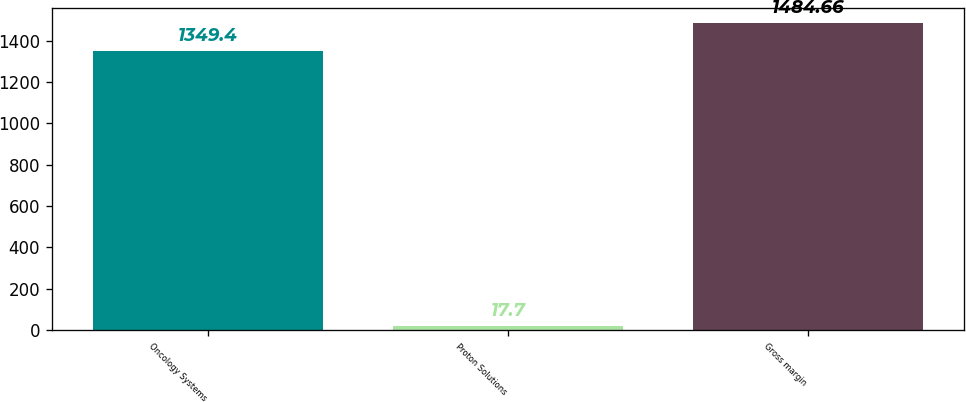Convert chart. <chart><loc_0><loc_0><loc_500><loc_500><bar_chart><fcel>Oncology Systems<fcel>Proton Solutions<fcel>Gross margin<nl><fcel>1349.4<fcel>17.7<fcel>1484.66<nl></chart> 